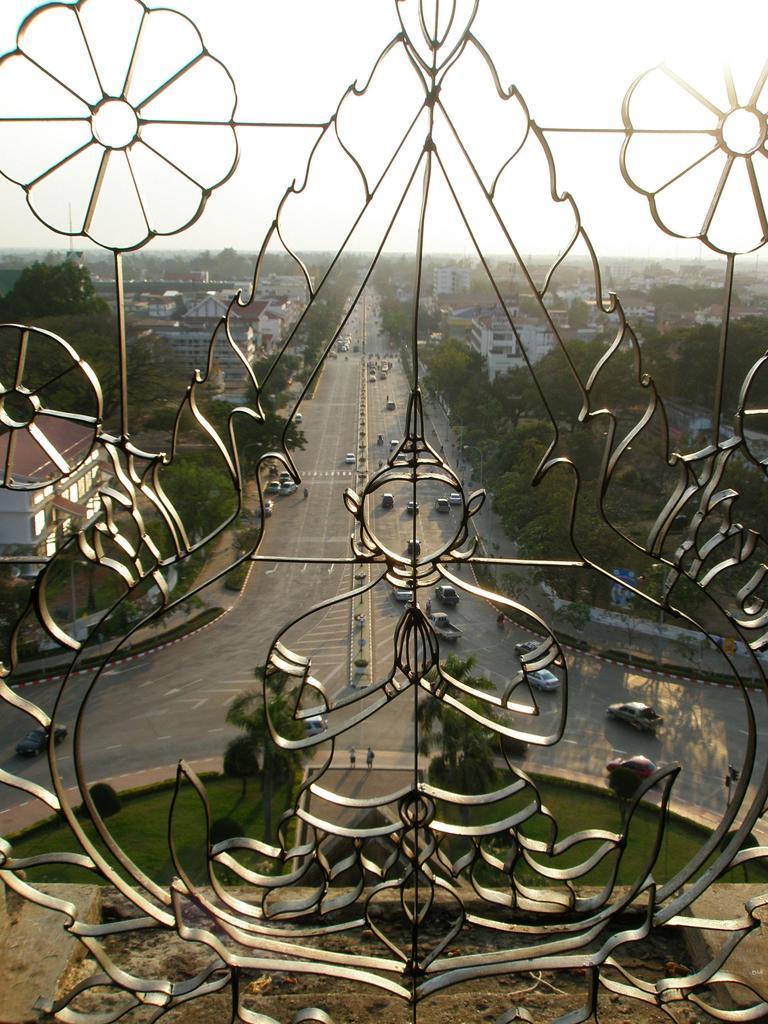Can you describe this image briefly? In this image I can see Iron bars. In the background I can see number of vehicles on these roads. I can also see number of trees, number of buildings and here I can see grass. 